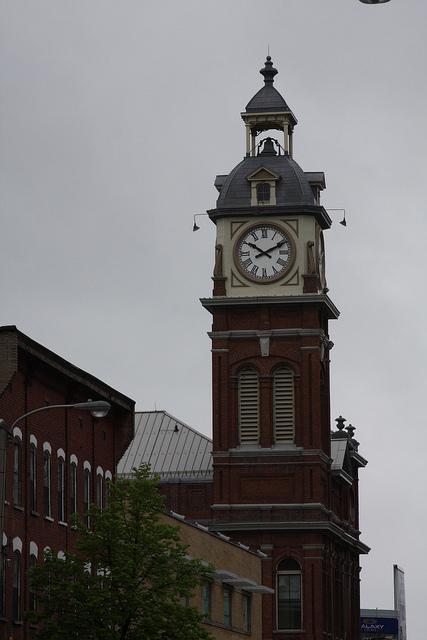How many windows above the clock?
Give a very brief answer. 1. How many clocks are on this tower?
Give a very brief answer. 1. 